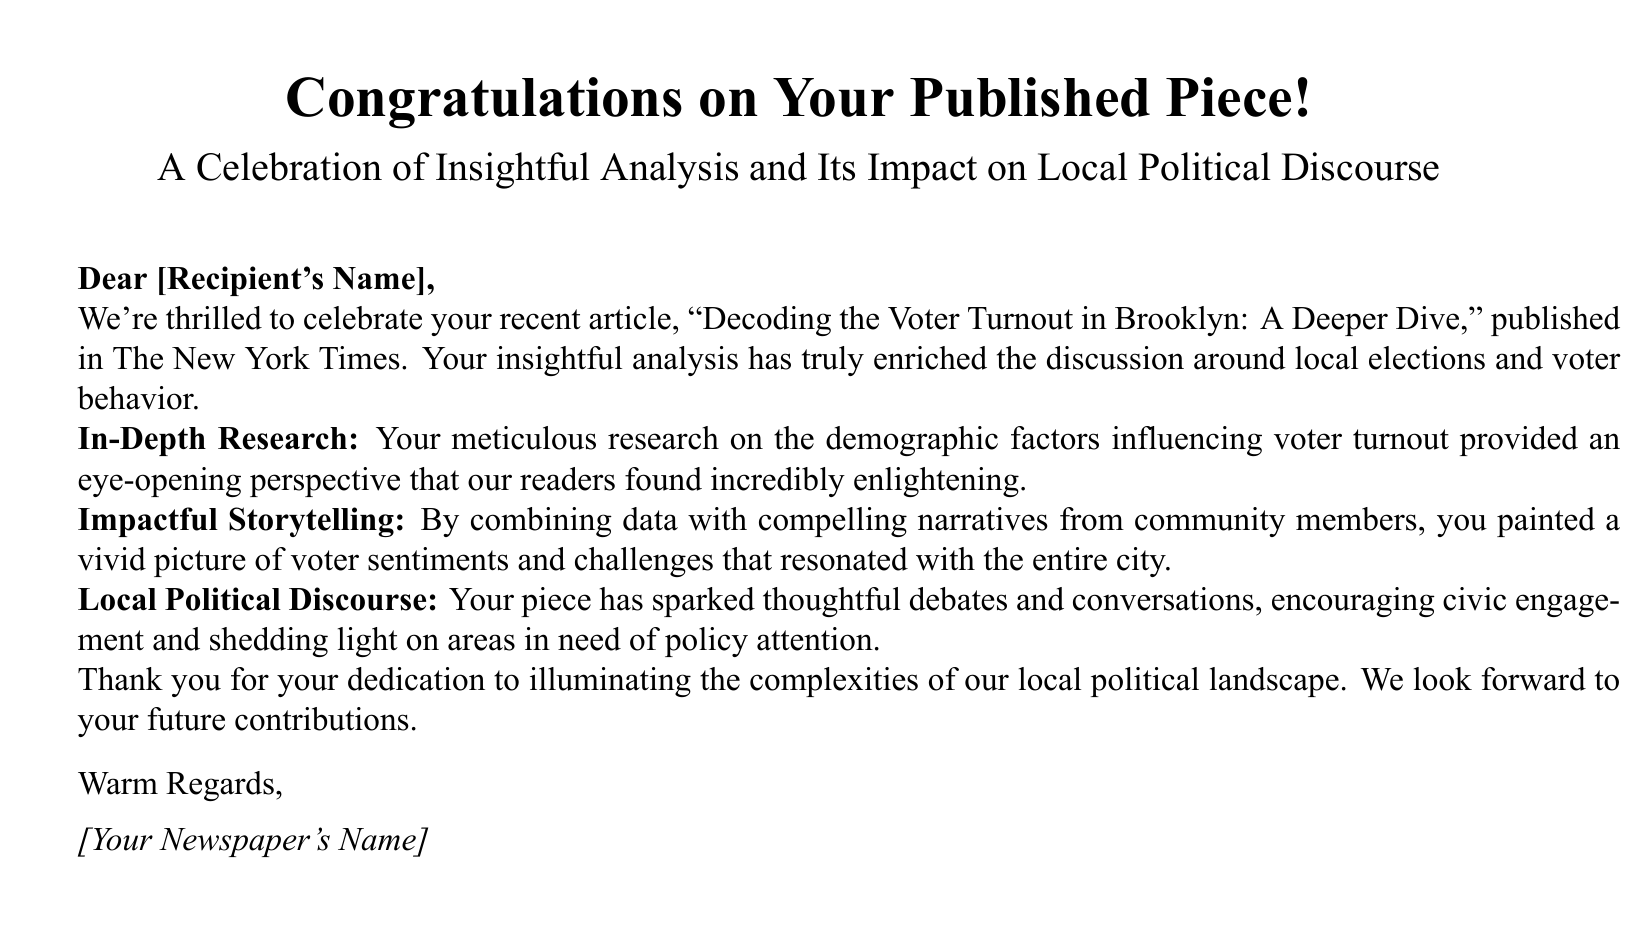What is the title of the published piece? The title provided in the card is an important detail highlighting the work being celebrated.
Answer: Decoding the Voter Turnout in Brooklyn: A Deeper Dive Who is the recipient of the card? The card is addressed to an individual, and the recipient's name would be filled in during personalization.
Answer: [Recipient's Name] What publication featured the article? The card mentions a specific publication important for recognizing where the work was published.
Answer: The New York Times What color are the stars on the card? The card uses a specific color for decorative elements, which adds to the visual appeal.
Answer: Gold What emoticon is used in the card's design? The use of a specific emoji reinforces the theme of writing and congratulating.
Answer: ✒ What is the main theme of the article highlighted in the card? The theme underscores the focus of the article, which relates to understanding voting behavior in a specific locality.
Answer: Voter turnout What effect did the article have on local political discourse? The impact described in the card emphasizes the article's role in promoting conversation and engagement around community issues.
Answer: Sparked thoughtful debates What type of storytelling is mentioned as part of the article's strength? This aspect highlights the narrative style used to convey complex ideas in an accessible way.
Answer: Impactful storytelling What is noted as a key element of the article's research? This detail demonstrates the thoroughness of the article, which is significant in academic and journalistic contexts.
Answer: In-Depth Research 